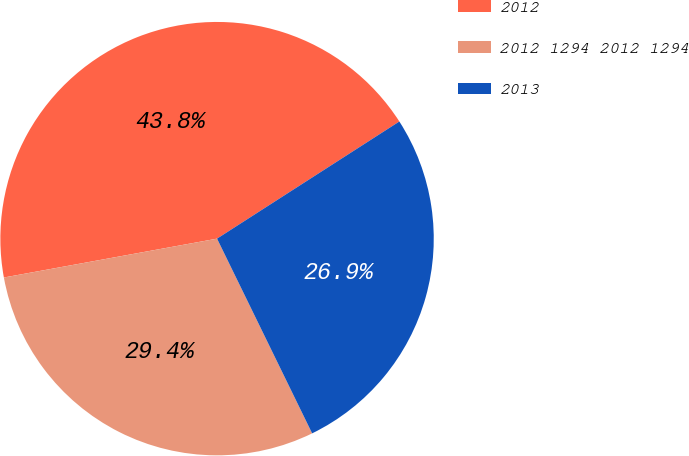<chart> <loc_0><loc_0><loc_500><loc_500><pie_chart><fcel>2012<fcel>2012 1294 2012 1294<fcel>2013<nl><fcel>43.78%<fcel>29.36%<fcel>26.86%<nl></chart> 